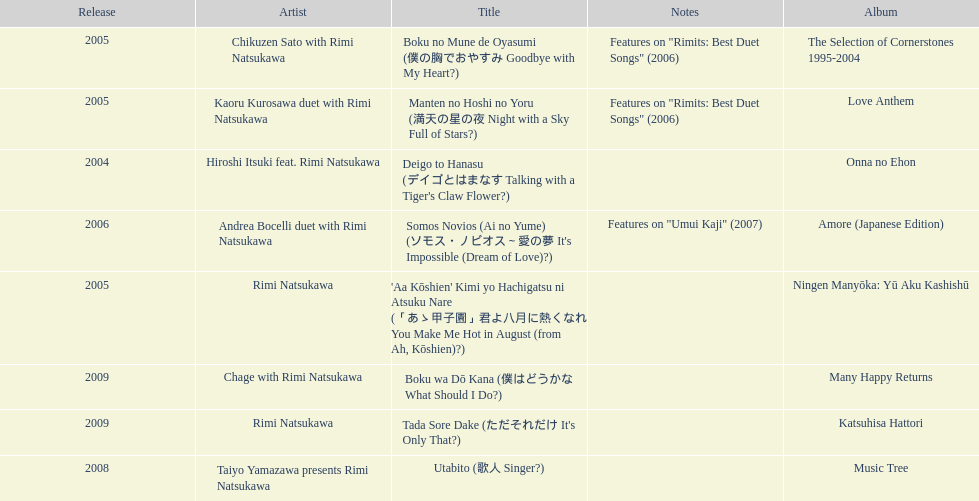Which year had the most titles released? 2005. 